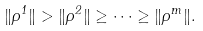Convert formula to latex. <formula><loc_0><loc_0><loc_500><loc_500>\| \rho ^ { 1 } \| > \| \rho ^ { 2 } \| \geq \cdots \geq \| \rho ^ { m } \| .</formula> 